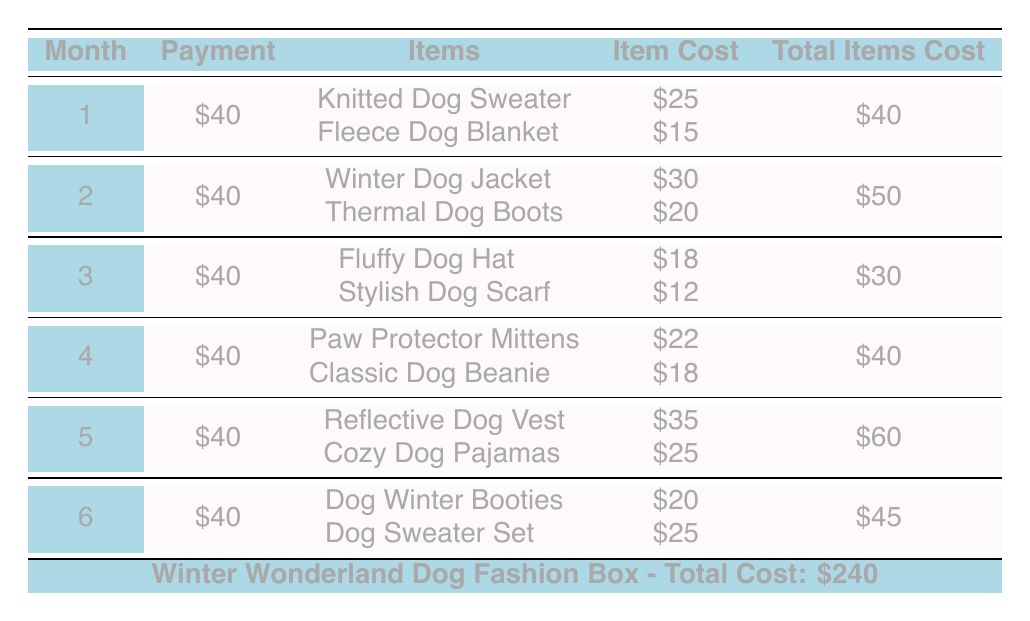What is the total subscription cost for the Winter Wonderland Dog Fashion Box? The table directly states the total subscription cost at the bottom of the table, which is $240.
Answer: 240 How much is the monthly payment for each month? Each month requires a payment of $40, as indicated in the "Payment" column for all six months.
Answer: 40 What is the total cost of items received in month 3? The table shows that in month 3, the total items cost is $30, which is directly provided in the "Total Items Cost" column for that month.
Answer: 30 Which month has the highest total items cost and what is that cost? By reviewing the "Total Items Cost" column, month 5 has the highest total items cost of $60, which is the highest value among all six months.
Answer: 60 Are there any months where the total items cost is less than $35? After comparing the total items cost for each month, months 3 ($30) and 1 ($40) have costs less than $35 (month 3 is the only month that meets this condition).
Answer: Yes What is the average total items cost across all six months? To calculate the average, sum the total items cost from each month (40 + 50 + 30 + 40 + 60 + 45 = 265) and divide by 6 months, yielding an average of approximately 44.17.
Answer: 44.17 How many items are included in month 4? Month 4 lists two items: Paw Protector Mittens and Classic Dog Beanie. The count of items for that month is therefore 2.
Answer: 2 Which item in month 5 has the higher cost and what is that cost? In month 5, the Reflective Dog Vest costs $35, while the Cozy Dog Pajamas cost $25. The higher cost is $35 for the Reflective Dog Vest.
Answer: 35 Is the total subscription cost evenly divided across the six months? Each month the payment amount is $40 and over six months, that totals $240 (40 * 6 = 240), indicating the total subscription cost is evenly divided across the months.
Answer: Yes 